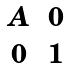Convert formula to latex. <formula><loc_0><loc_0><loc_500><loc_500>\begin{matrix} A & 0 \\ 0 & 1 \end{matrix}</formula> 